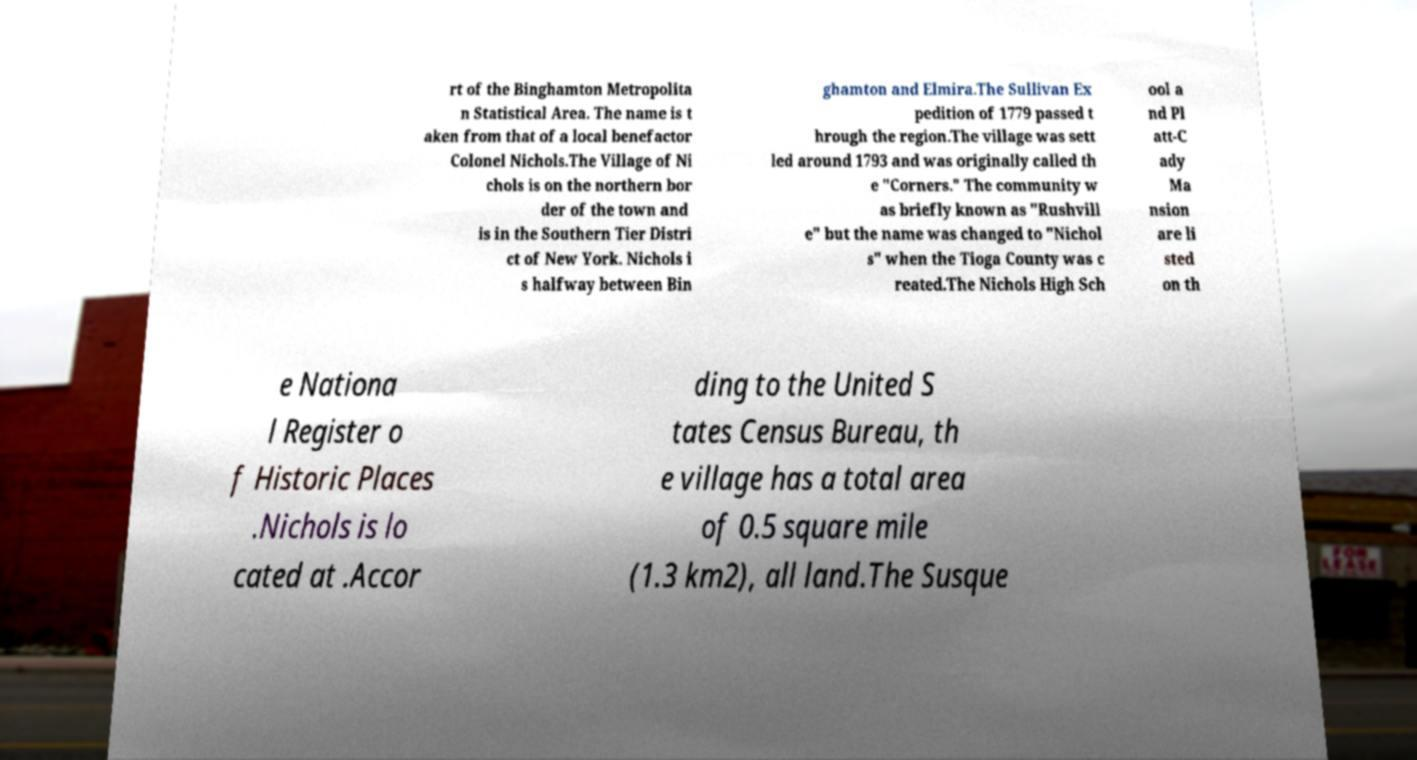What messages or text are displayed in this image? I need them in a readable, typed format. rt of the Binghamton Metropolita n Statistical Area. The name is t aken from that of a local benefactor Colonel Nichols.The Village of Ni chols is on the northern bor der of the town and is in the Southern Tier Distri ct of New York. Nichols i s halfway between Bin ghamton and Elmira.The Sullivan Ex pedition of 1779 passed t hrough the region.The village was sett led around 1793 and was originally called th e "Corners." The community w as briefly known as "Rushvill e" but the name was changed to "Nichol s" when the Tioga County was c reated.The Nichols High Sch ool a nd Pl att-C ady Ma nsion are li sted on th e Nationa l Register o f Historic Places .Nichols is lo cated at .Accor ding to the United S tates Census Bureau, th e village has a total area of 0.5 square mile (1.3 km2), all land.The Susque 